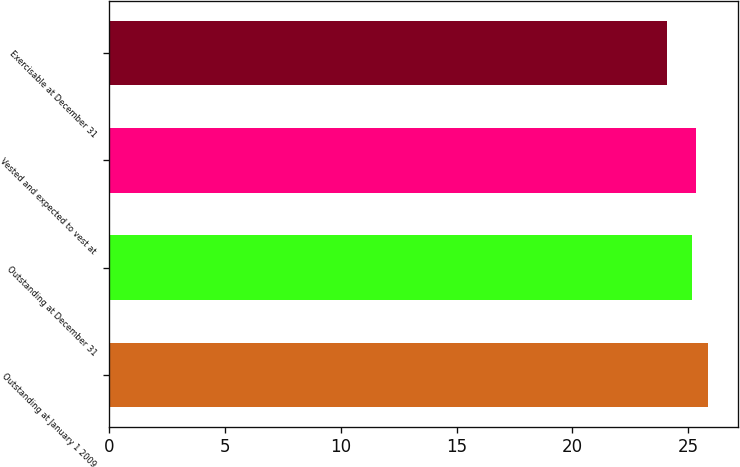Convert chart to OTSL. <chart><loc_0><loc_0><loc_500><loc_500><bar_chart><fcel>Outstanding at January 1 2009<fcel>Outstanding at December 31<fcel>Vested and expected to vest at<fcel>Exercisable at December 31<nl><fcel>25.87<fcel>25.14<fcel>25.32<fcel>24.08<nl></chart> 